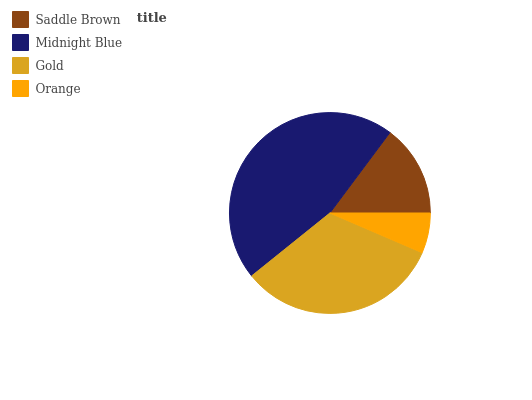Is Orange the minimum?
Answer yes or no. Yes. Is Midnight Blue the maximum?
Answer yes or no. Yes. Is Gold the minimum?
Answer yes or no. No. Is Gold the maximum?
Answer yes or no. No. Is Midnight Blue greater than Gold?
Answer yes or no. Yes. Is Gold less than Midnight Blue?
Answer yes or no. Yes. Is Gold greater than Midnight Blue?
Answer yes or no. No. Is Midnight Blue less than Gold?
Answer yes or no. No. Is Gold the high median?
Answer yes or no. Yes. Is Saddle Brown the low median?
Answer yes or no. Yes. Is Midnight Blue the high median?
Answer yes or no. No. Is Gold the low median?
Answer yes or no. No. 